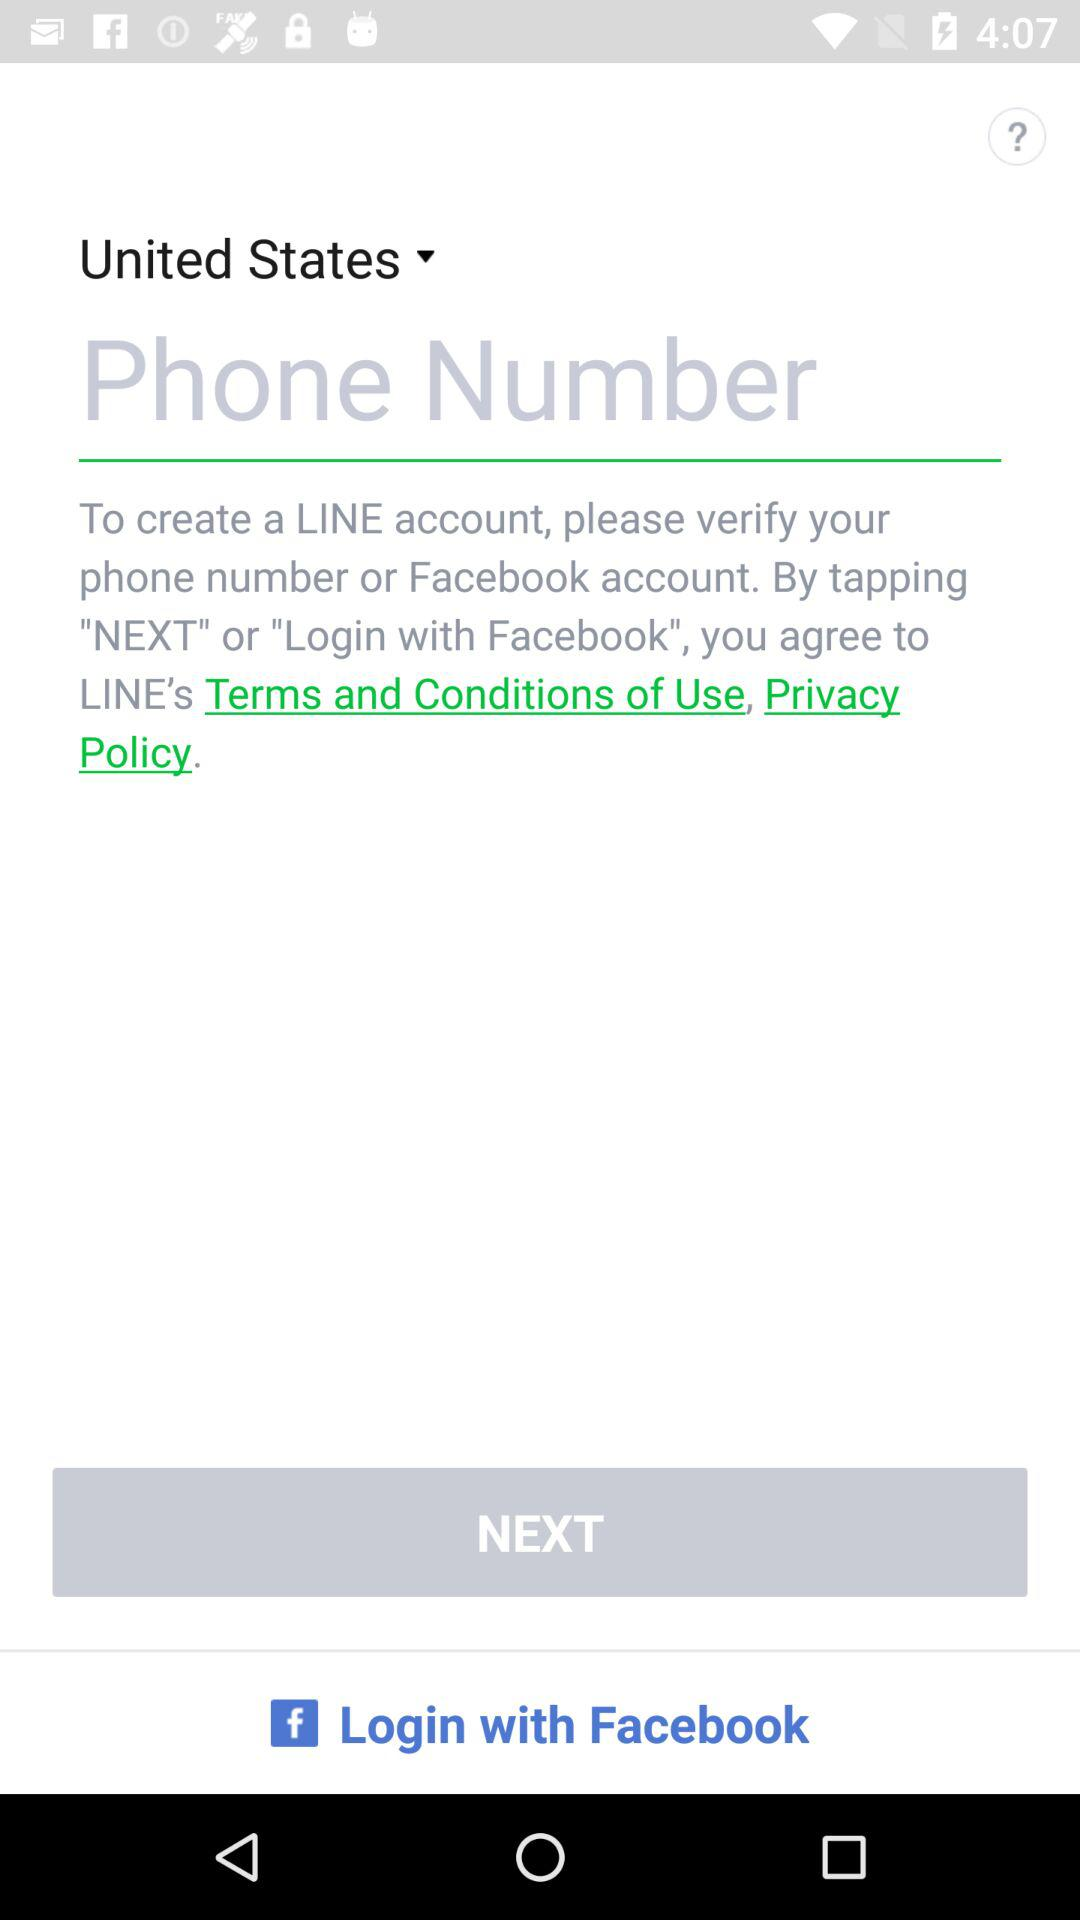What is the country's name? The country's name is the "United States". 